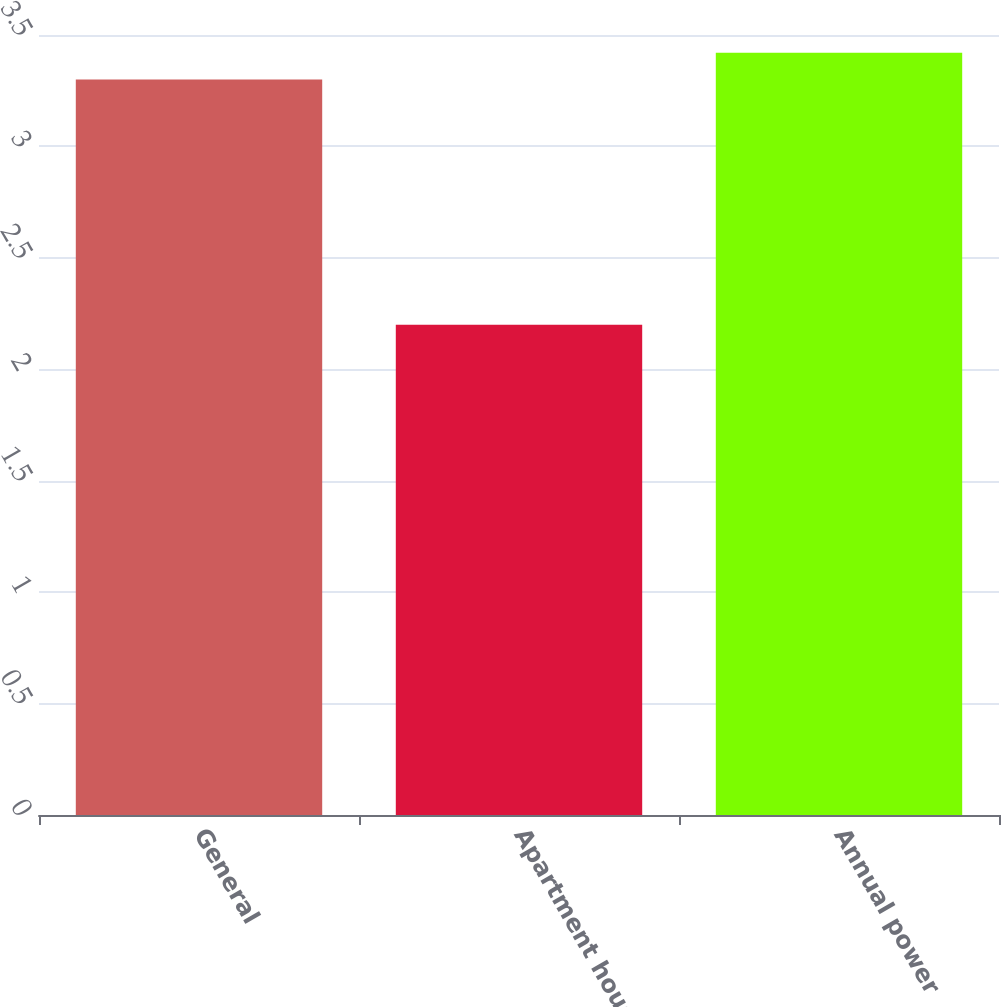Convert chart. <chart><loc_0><loc_0><loc_500><loc_500><bar_chart><fcel>General<fcel>Apartment house<fcel>Annual power<nl><fcel>3.3<fcel>2.2<fcel>3.42<nl></chart> 